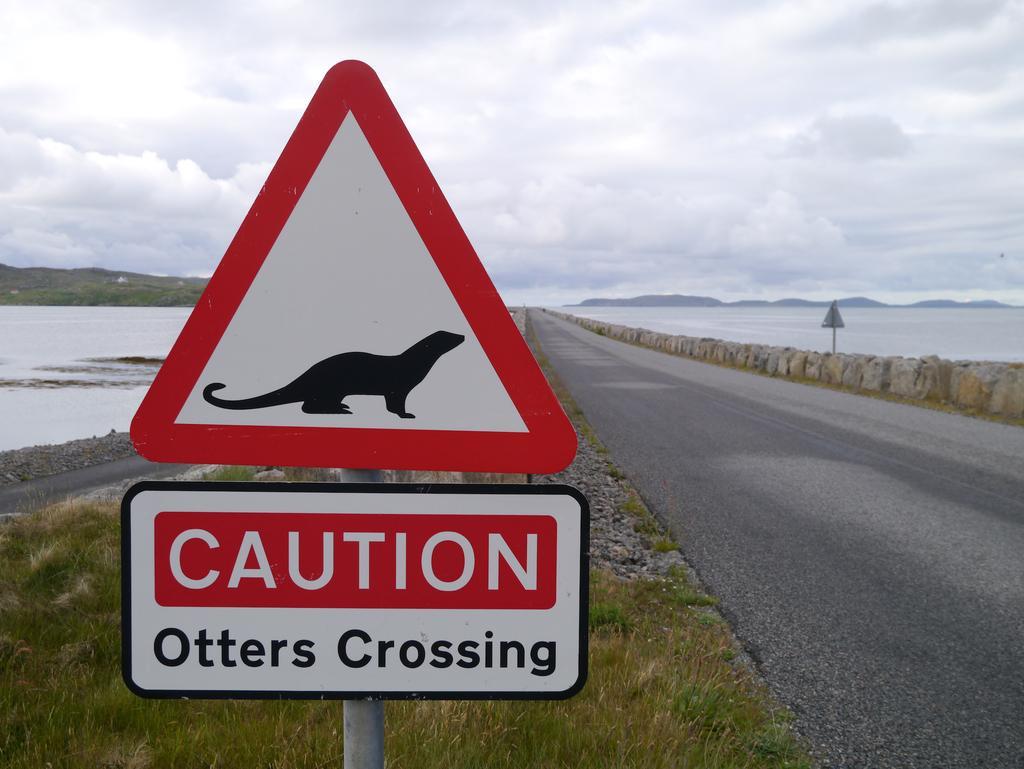How would you summarize this image in a sentence or two? There is a signboard and a hoarding attached to the pole near grass on the ground. On the right side, there is a road near a small wall. In the background, there is water, mountains and clouds in the sky. 